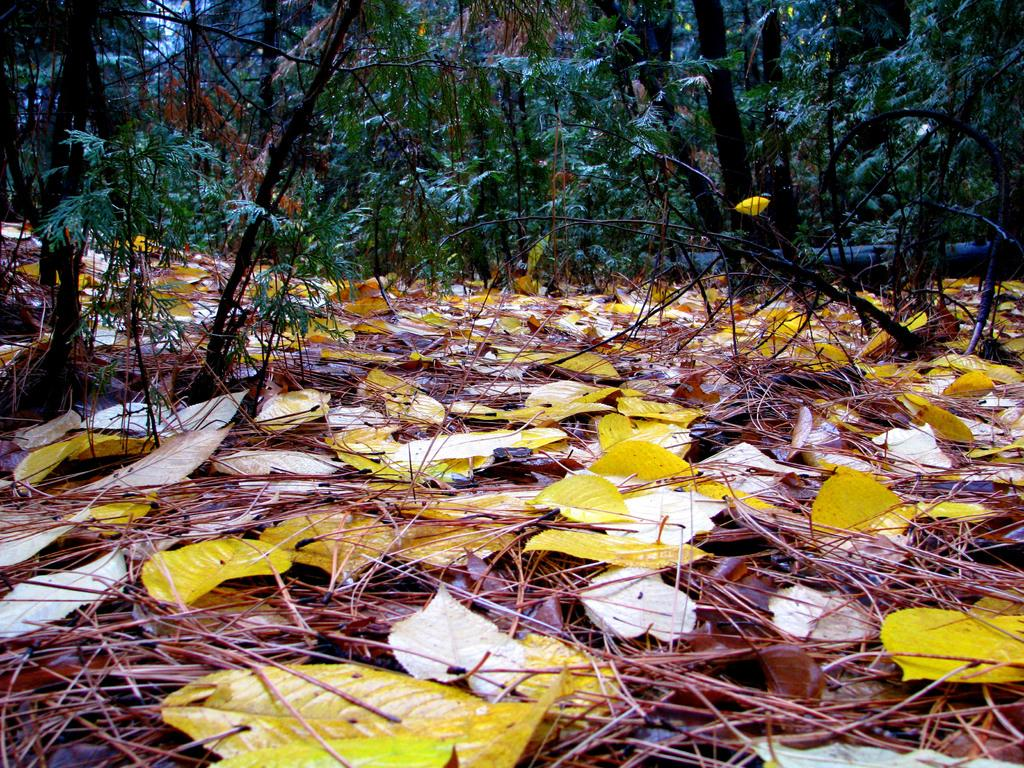What type of natural elements can be seen in the image? There are dry leaves and grass in the image. What else can be observed in the image? There are a lot of plants in the image. What type of wall can be seen in the image? There is no wall present in the image; it features dry leaves, grass, and plants. Can you find a receipt in the image? There is no receipt present in the image. 